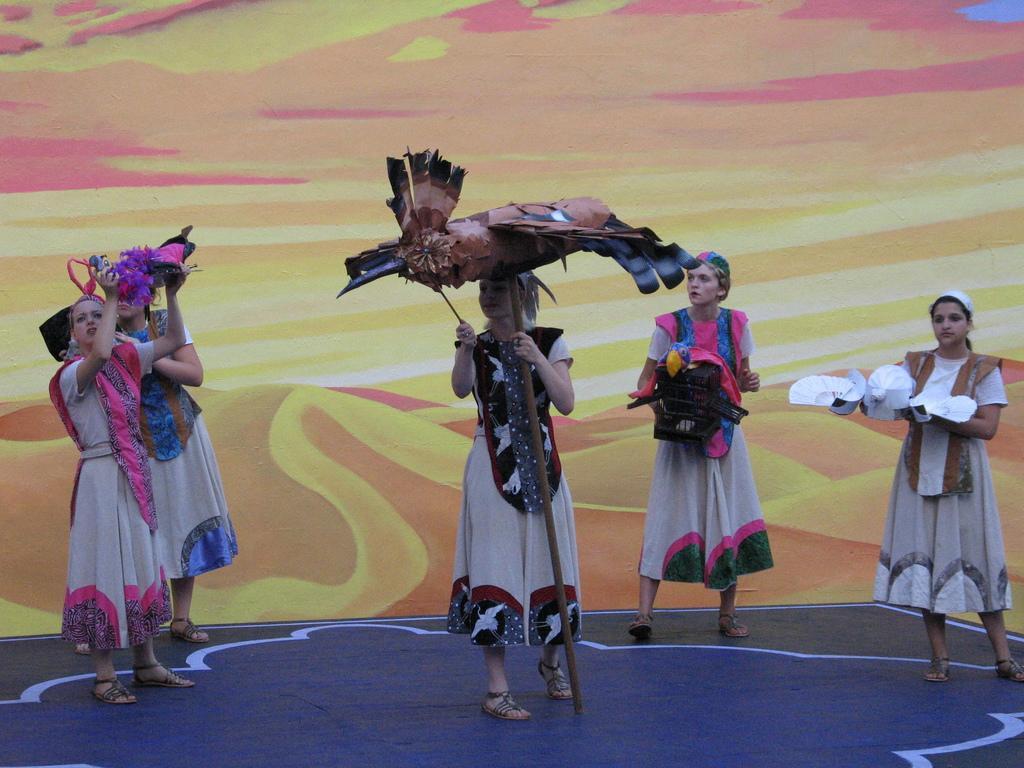In one or two sentences, can you explain what this image depicts? In the image there are a group of women, they are wearing different costumes and holding some objects in their hands. 